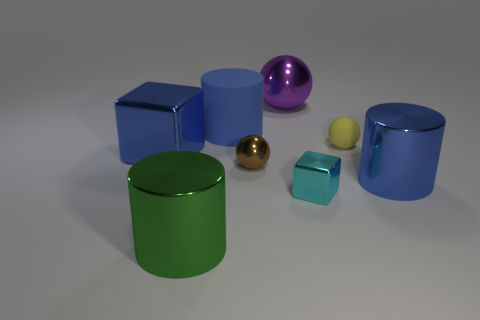The tiny rubber ball has what color?
Keep it short and to the point. Yellow. There is a cylinder that is left of the large matte cylinder; is its size the same as the cube that is on the right side of the purple ball?
Your answer should be very brief. No. There is a ball that is in front of the purple sphere and to the left of the small rubber sphere; how big is it?
Ensure brevity in your answer.  Small. What is the color of the other rubber thing that is the same shape as the large green thing?
Provide a succinct answer. Blue. Are there more small matte things that are on the right side of the brown metallic sphere than yellow spheres behind the yellow matte thing?
Keep it short and to the point. Yes. How many other things are there of the same shape as the purple metallic thing?
Offer a terse response. 2. Are there any matte cylinders that are left of the big blue metallic object left of the purple shiny thing?
Ensure brevity in your answer.  No. What number of tiny balls are there?
Ensure brevity in your answer.  2. Does the big metallic sphere have the same color as the metallic sphere that is in front of the blue matte object?
Offer a very short reply. No. Is the number of large blue metal cylinders greater than the number of tiny cyan balls?
Give a very brief answer. Yes. 